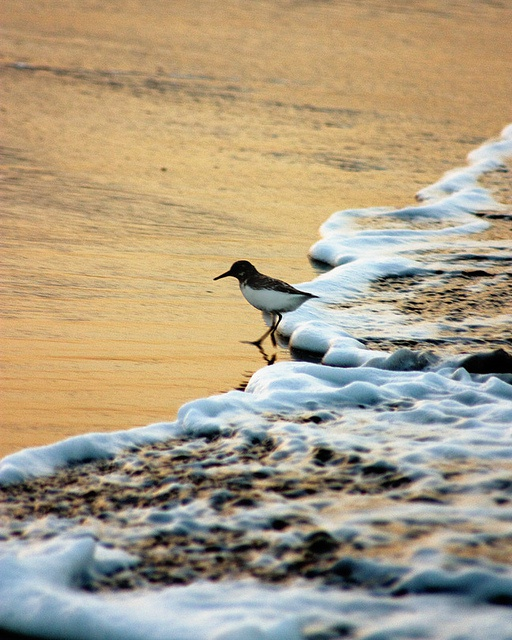Describe the objects in this image and their specific colors. I can see a bird in tan, black, darkgray, and gray tones in this image. 